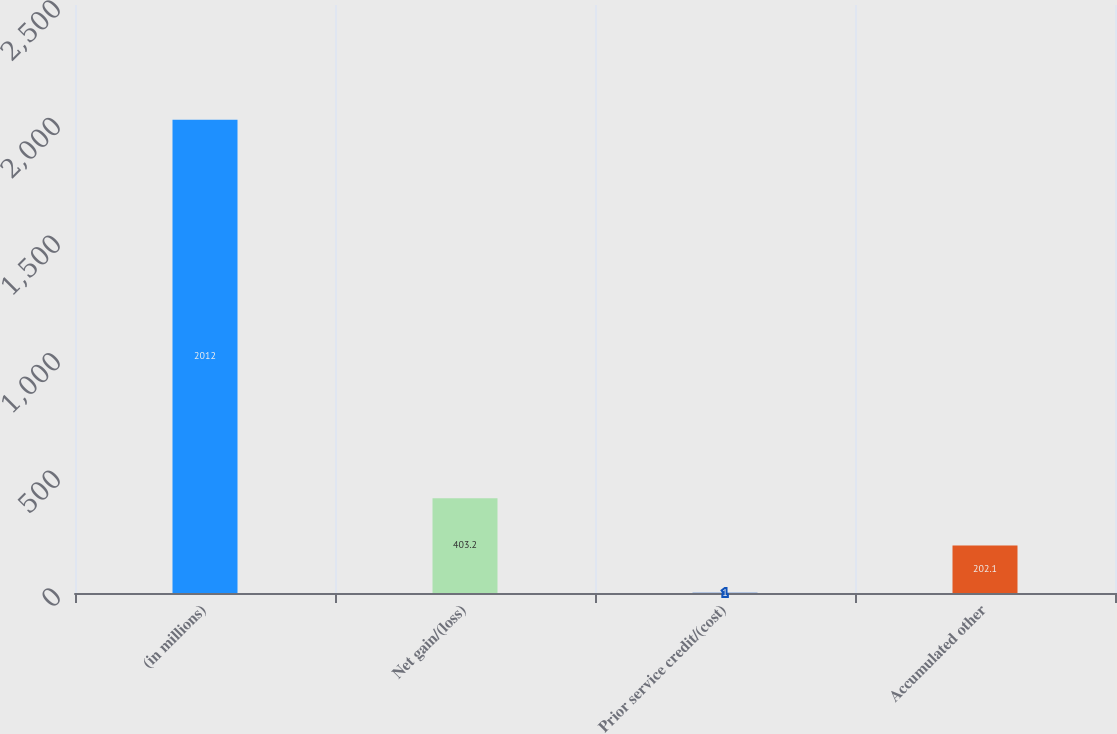Convert chart. <chart><loc_0><loc_0><loc_500><loc_500><bar_chart><fcel>(in millions)<fcel>Net gain/(loss)<fcel>Prior service credit/(cost)<fcel>Accumulated other<nl><fcel>2012<fcel>403.2<fcel>1<fcel>202.1<nl></chart> 